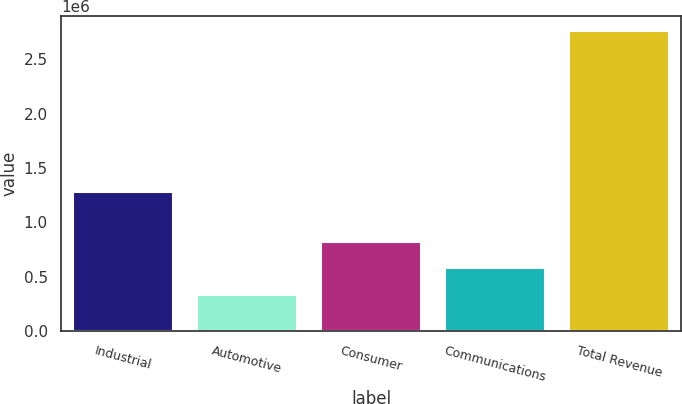Convert chart to OTSL. <chart><loc_0><loc_0><loc_500><loc_500><bar_chart><fcel>Industrial<fcel>Automotive<fcel>Consumer<fcel>Communications<fcel>Total Revenue<nl><fcel>1.28003e+06<fcel>335163<fcel>820431<fcel>577797<fcel>2.7615e+06<nl></chart> 